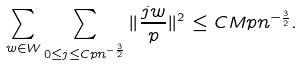Convert formula to latex. <formula><loc_0><loc_0><loc_500><loc_500>\sum _ { w \in W } \sum _ { 0 \leq j \leq C p n ^ { - \frac { 3 } { 2 } } } \| \frac { j w } { p } \| ^ { 2 } \leq C M p n ^ { - \frac { 3 } { 2 } } .</formula> 